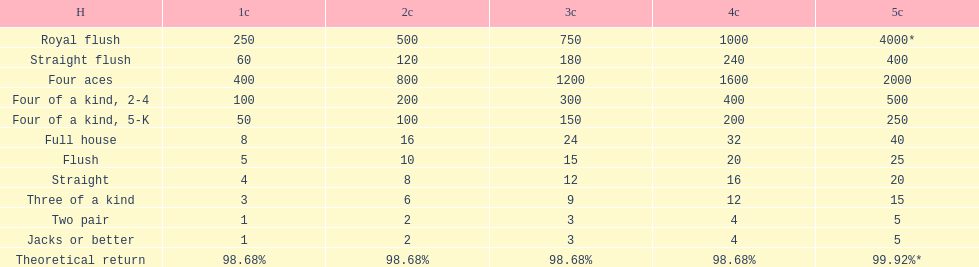What is the difference of payout on 3 credits, between a straight flush and royal flush? 570. 